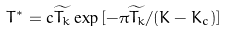Convert formula to latex. <formula><loc_0><loc_0><loc_500><loc_500>T ^ { * } = c \widetilde { T _ { k } } \exp { [ - \pi \widetilde { T _ { k } } / ( K - K _ { c } ) ] }</formula> 